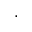<formula> <loc_0><loc_0><loc_500><loc_500>,</formula> 